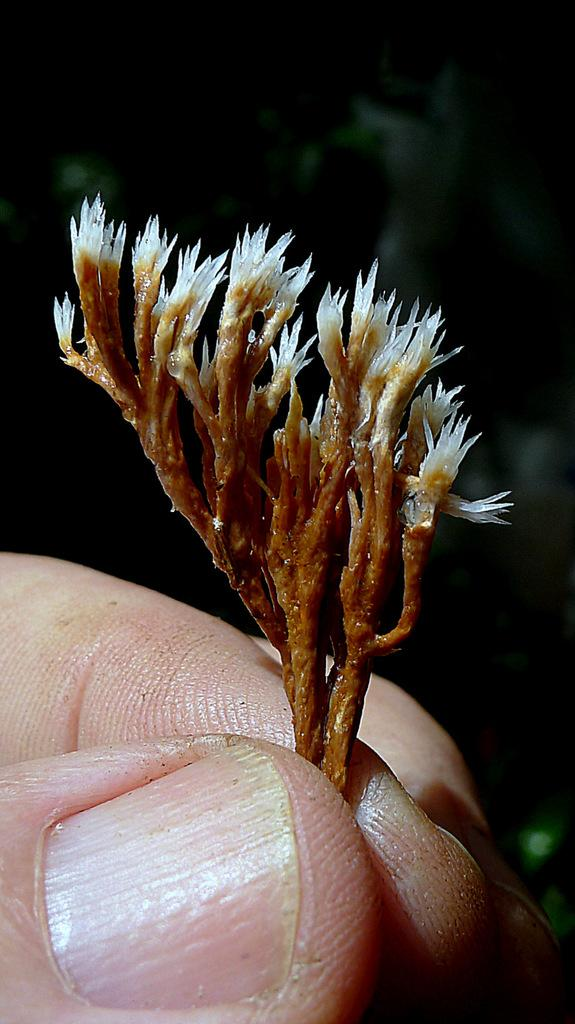What part of a person can be seen in the image? There are fingers of a person visible in the image. What is the person holding in the image? The person is holding flowers. What is the color or lighting condition of the background in the image? The background of the image is dark. What type of bun is being prepared by the person in the image? There is no bun or any indication of food preparation in the image; the person is holding flowers. 